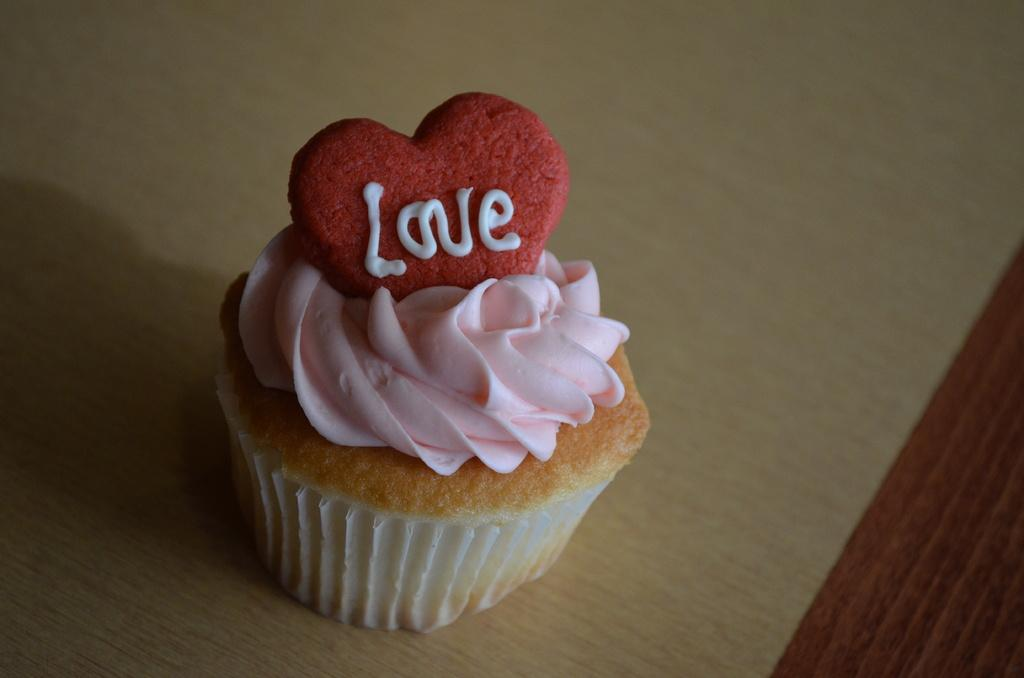What type of dessert is in the image? There is a cupcake in the image. What is on top of the cupcake? The cupcake has frosting. On what surface is the cupcake placed? The cupcake is placed on a wooden surface. Where is the goat in the image? There is no goat present in the image. What type of wall is visible in the image? There is no wall visible in the image. 